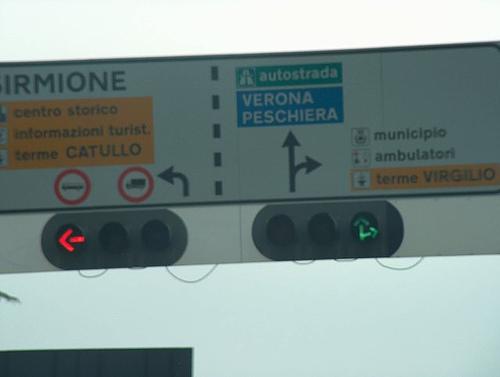Is this sign written in English?
Concise answer only. No. Which direction should you not go?
Answer briefly. Left. Can music be plane in this?
Write a very short answer. No. 